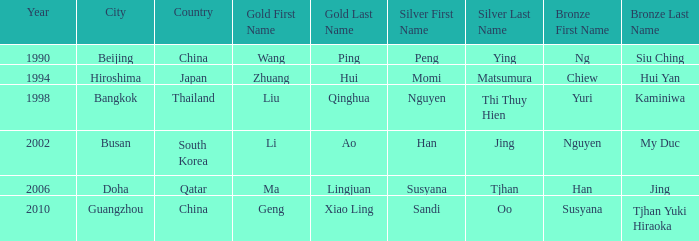What Gold has the Year of 2006? Ma Lingjuan. 